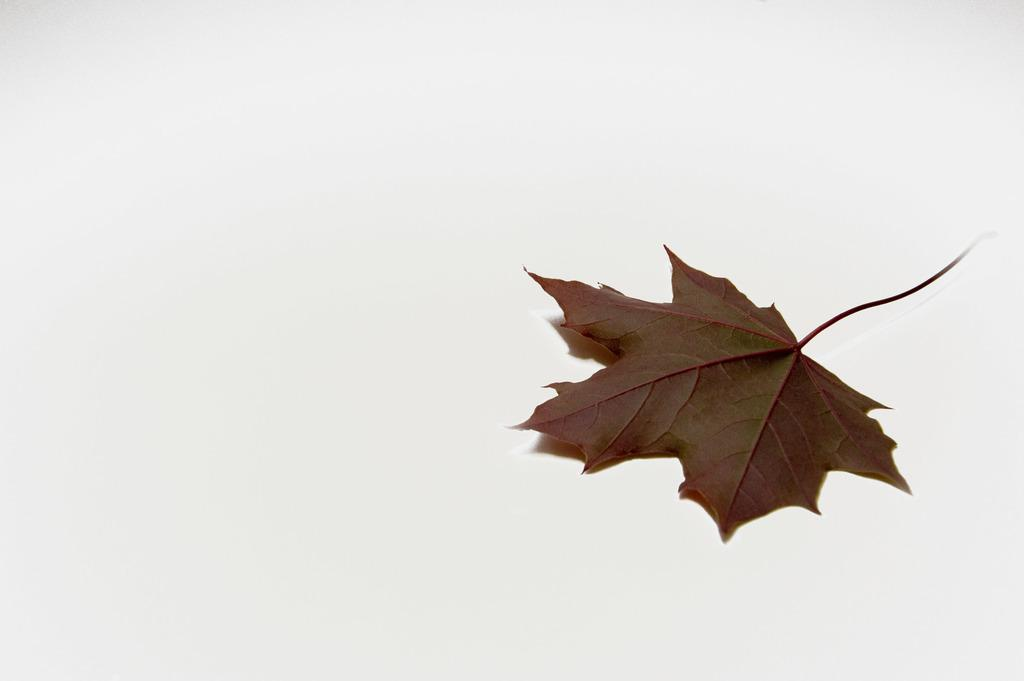What is present on the floor in the image? There is a leaf on the floor in the image. What color is the leaf? The leaf is brown in color. What can be seen in the background of the image? The background of the image is white. What type of grain is being thought about by the leaf in the image? There is no indication that the leaf is thinking about anything, let alone grain, in the image. 